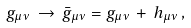<formula> <loc_0><loc_0><loc_500><loc_500>g _ { \mu \nu } \, \rightarrow \, \bar { g } _ { \mu \nu } = g _ { \mu \nu } \, + \, h _ { \mu \nu } \, ,</formula> 